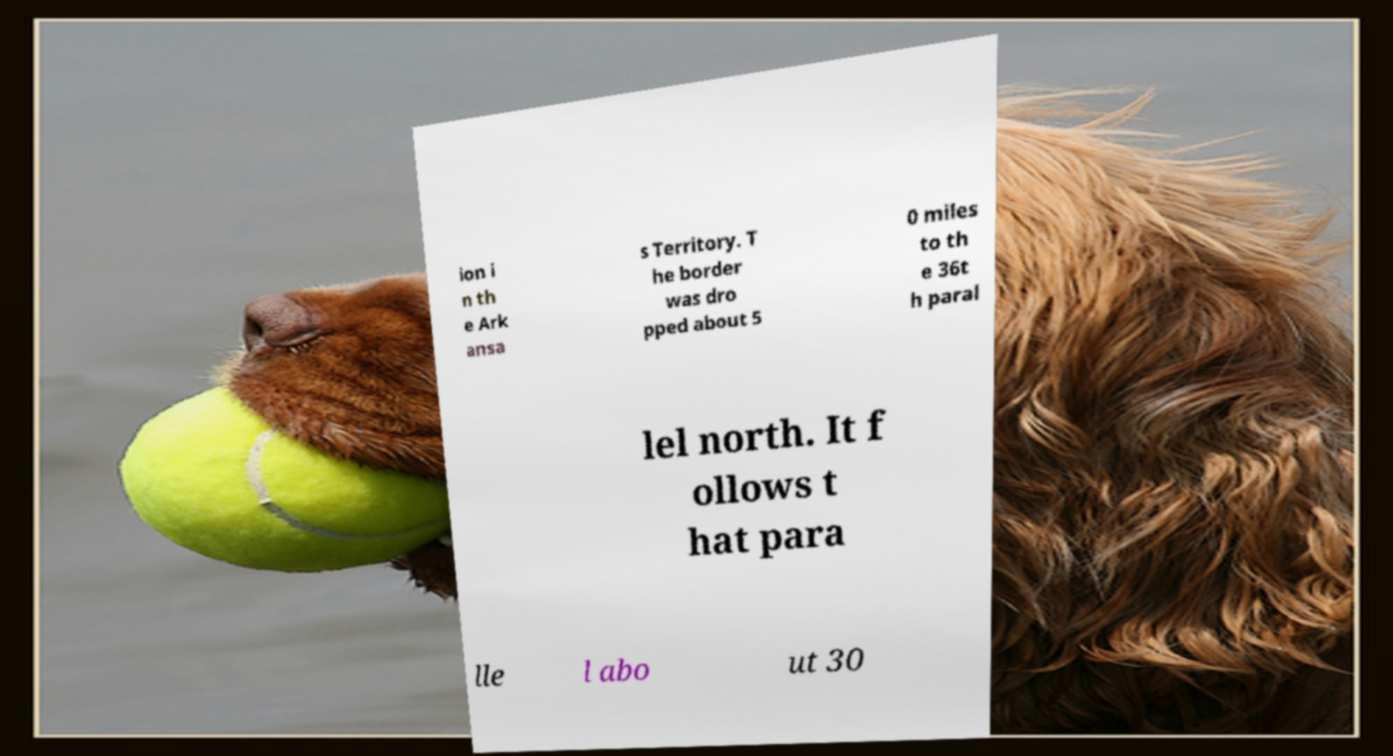Please read and relay the text visible in this image. What does it say? ion i n th e Ark ansa s Territory. T he border was dro pped about 5 0 miles to th e 36t h paral lel north. It f ollows t hat para lle l abo ut 30 